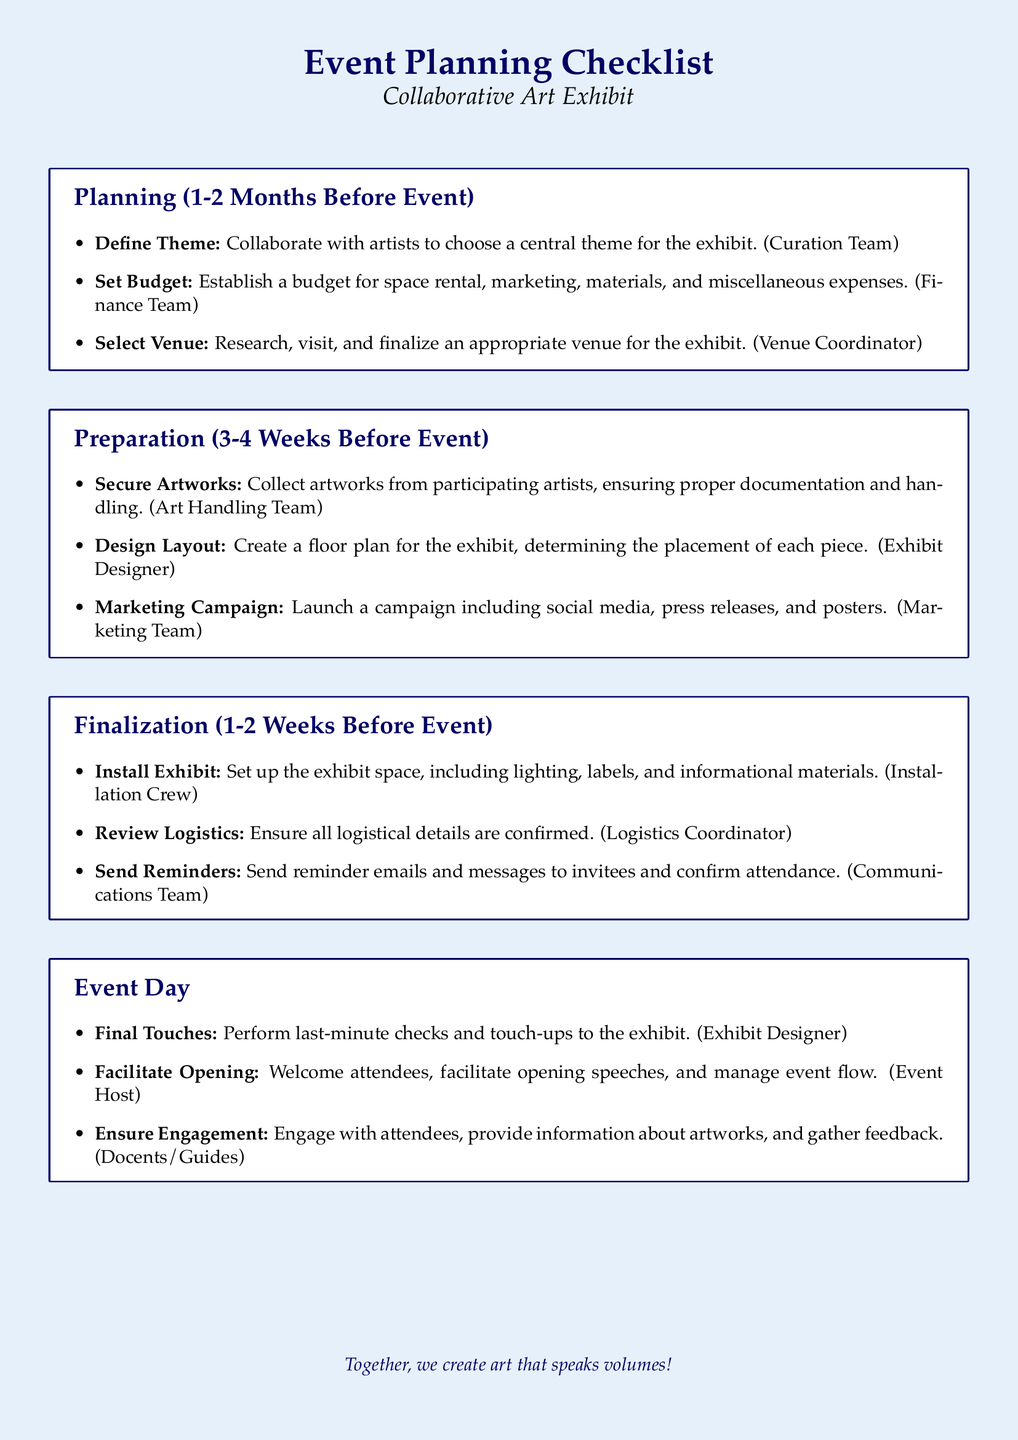What is the main purpose of the document? The document outlines a checklist for organizing a collaborative art exhibit, detailing tasks, timelines, and responsible participants.
Answer: Event Planning Checklist How many months before the event should the planning phase begin? The document specifies that the planning phase should start 1-2 months before the event.
Answer: 1-2 Months Who is responsible for defining the theme of the exhibit? The Curation Team is tasked with collaborating with artists to choose a central theme.
Answer: Curation Team What task involves the installation of the exhibit? The task is to set up the exhibit space, including lighting and labels.
Answer: Install Exhibit What is the role of the Logistics Coordinator during the finalization phase? The Logistics Coordinator is responsible for ensuring all logistical details are confirmed.
Answer: Review Logistics During the event day, who welcomes attendees? The Event Host is responsible for welcoming attendees and facilitating opening speeches.
Answer: Event Host What is the focus of the marketing campaign preparation? The marketing campaign should include social media, press releases, and posters to promote the event.
Answer: Marketing Campaign What is the key task to be completed 3-4 weeks before the event? Collect artworks from participating artists and ensure proper documentation and handling.
Answer: Secure Artworks When should reminder emails be sent? Reminder emails should be sent 1-2 weeks before the event to confirm attendance.
Answer: 1-2 Weeks Before Event 